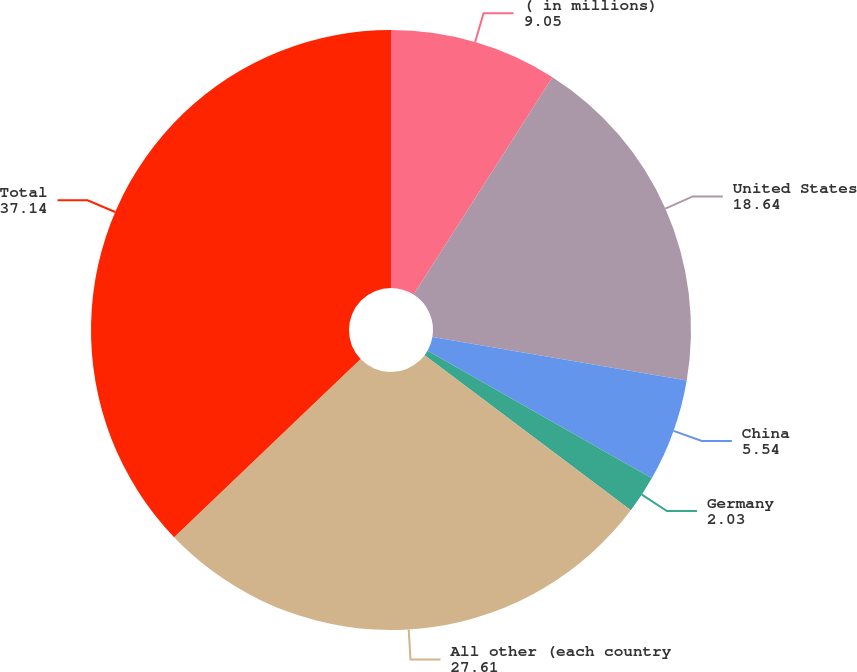<chart> <loc_0><loc_0><loc_500><loc_500><pie_chart><fcel>( in millions)<fcel>United States<fcel>China<fcel>Germany<fcel>All other (each country<fcel>Total<nl><fcel>9.05%<fcel>18.64%<fcel>5.54%<fcel>2.03%<fcel>27.61%<fcel>37.14%<nl></chart> 